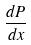Convert formula to latex. <formula><loc_0><loc_0><loc_500><loc_500>\frac { d P } { d x }</formula> 